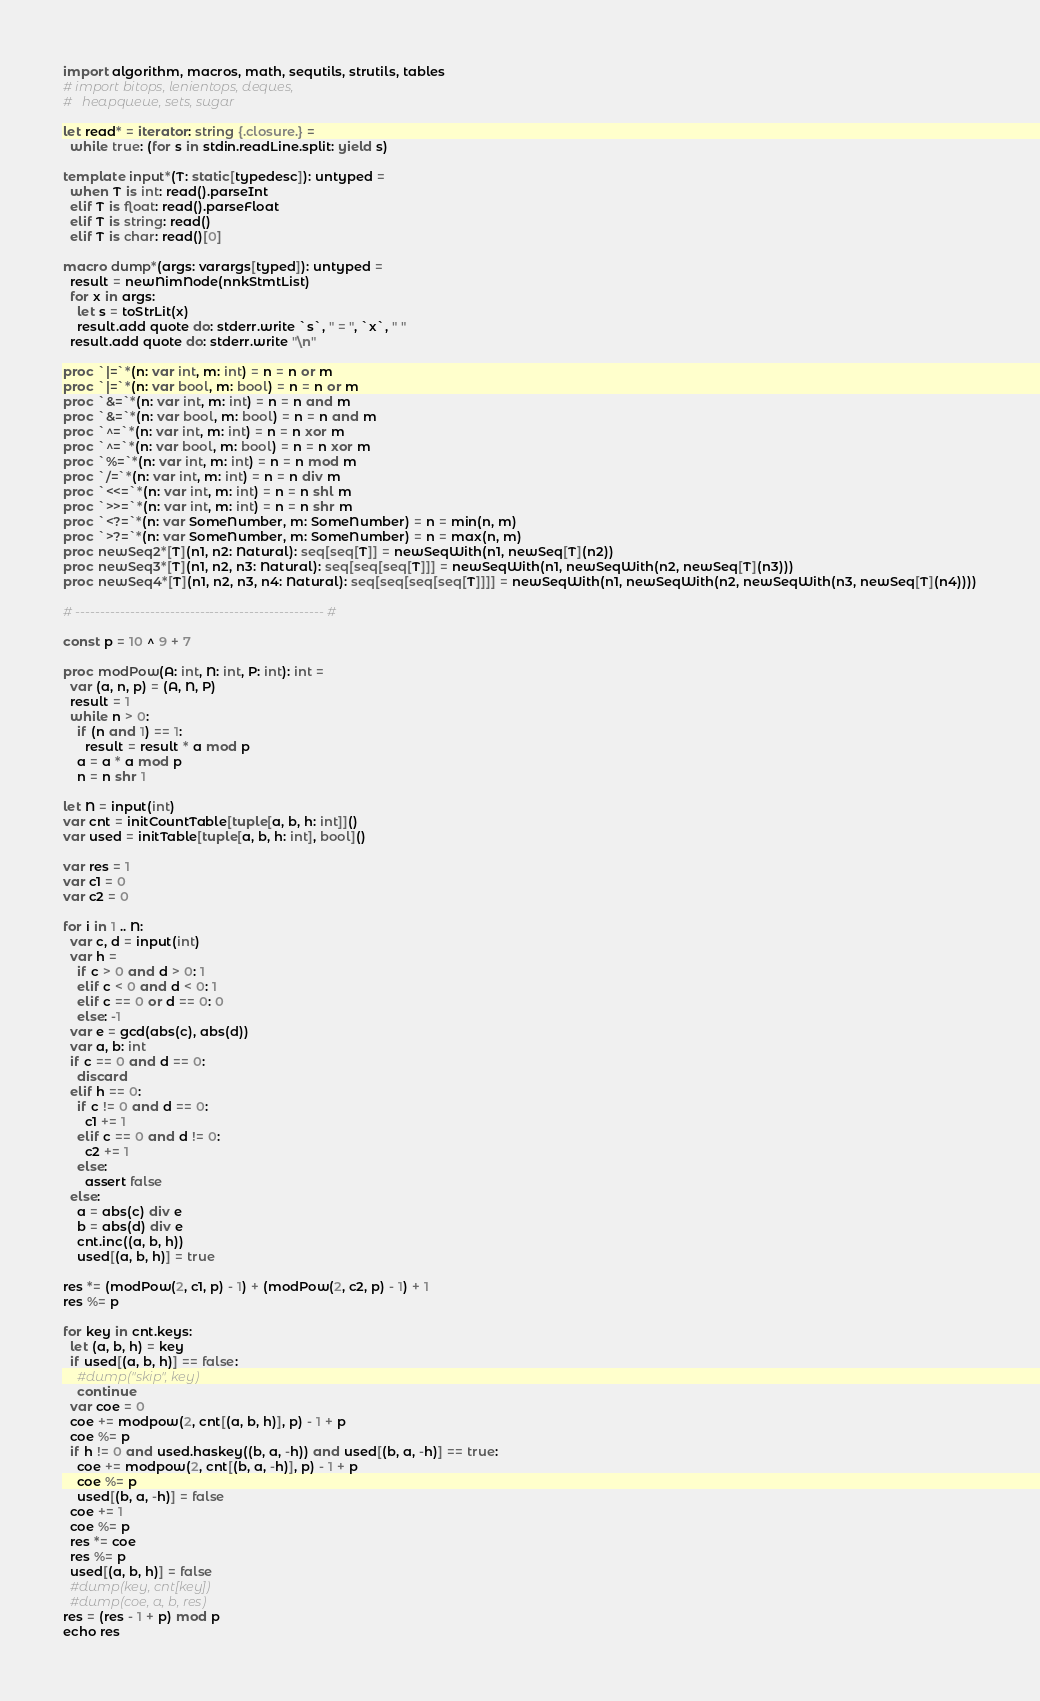Convert code to text. <code><loc_0><loc_0><loc_500><loc_500><_Nim_>import algorithm, macros, math, sequtils, strutils, tables
# import bitops, lenientops, deques,
#   heapqueue, sets, sugar
 
let read* = iterator: string {.closure.} =
  while true: (for s in stdin.readLine.split: yield s)
 
template input*(T: static[typedesc]): untyped = 
  when T is int: read().parseInt
  elif T is float: read().parseFloat
  elif T is string: read()
  elif T is char: read()[0]
 
macro dump*(args: varargs[typed]): untyped =
  result = newNimNode(nnkStmtList)
  for x in args:
    let s = toStrLit(x)
    result.add quote do: stderr.write `s`, " = ", `x`, " "
  result.add quote do: stderr.write "\n"
 
proc `|=`*(n: var int, m: int) = n = n or m
proc `|=`*(n: var bool, m: bool) = n = n or m
proc `&=`*(n: var int, m: int) = n = n and m
proc `&=`*(n: var bool, m: bool) = n = n and m
proc `^=`*(n: var int, m: int) = n = n xor m
proc `^=`*(n: var bool, m: bool) = n = n xor m
proc `%=`*(n: var int, m: int) = n = n mod m
proc `/=`*(n: var int, m: int) = n = n div m
proc `<<=`*(n: var int, m: int) = n = n shl m
proc `>>=`*(n: var int, m: int) = n = n shr m
proc `<?=`*(n: var SomeNumber, m: SomeNumber) = n = min(n, m)
proc `>?=`*(n: var SomeNumber, m: SomeNumber) = n = max(n, m)
proc newSeq2*[T](n1, n2: Natural): seq[seq[T]] = newSeqWith(n1, newSeq[T](n2))
proc newSeq3*[T](n1, n2, n3: Natural): seq[seq[seq[T]]] = newSeqWith(n1, newSeqWith(n2, newSeq[T](n3)))
proc newSeq4*[T](n1, n2, n3, n4: Natural): seq[seq[seq[seq[T]]]] = newSeqWith(n1, newSeqWith(n2, newSeqWith(n3, newSeq[T](n4))))
 
# -------------------------------------------------- #

const p = 10 ^ 9 + 7

proc modPow(A: int, N: int, P: int): int =
  var (a, n, p) = (A, N, P)
  result = 1
  while n > 0:
    if (n and 1) == 1:
      result = result * a mod p
    a = a * a mod p
    n = n shr 1

let N = input(int)
var cnt = initCountTable[tuple[a, b, h: int]]()
var used = initTable[tuple[a, b, h: int], bool]()

var res = 1
var c1 = 0
var c2 = 0

for i in 1 .. N:
  var c, d = input(int)
  var h =
    if c > 0 and d > 0: 1
    elif c < 0 and d < 0: 1
    elif c == 0 or d == 0: 0
    else: -1
  var e = gcd(abs(c), abs(d))
  var a, b: int
  if c == 0 and d == 0:
    discard
  elif h == 0:
    if c != 0 and d == 0:
      c1 += 1
    elif c == 0 and d != 0:
      c2 += 1
    else:
      assert false
  else:
    a = abs(c) div e
    b = abs(d) div e
    cnt.inc((a, b, h))
    used[(a, b, h)] = true

res *= (modPow(2, c1, p) - 1) + (modPow(2, c2, p) - 1) + 1
res %= p

for key in cnt.keys:
  let (a, b, h) = key
  if used[(a, b, h)] == false:
    #dump("skip", key)
    continue
  var coe = 0
  coe += modpow(2, cnt[(a, b, h)], p) - 1 + p
  coe %= p
  if h != 0 and used.haskey((b, a, -h)) and used[(b, a, -h)] == true:
    coe += modpow(2, cnt[(b, a, -h)], p) - 1 + p
    coe %= p
    used[(b, a, -h)] = false
  coe += 1
  coe %= p
  res *= coe
  res %= p
  used[(a, b, h)] = false
  #dump(key, cnt[key])
  #dump(coe, a, b, res)
res = (res - 1 + p) mod p
echo res</code> 